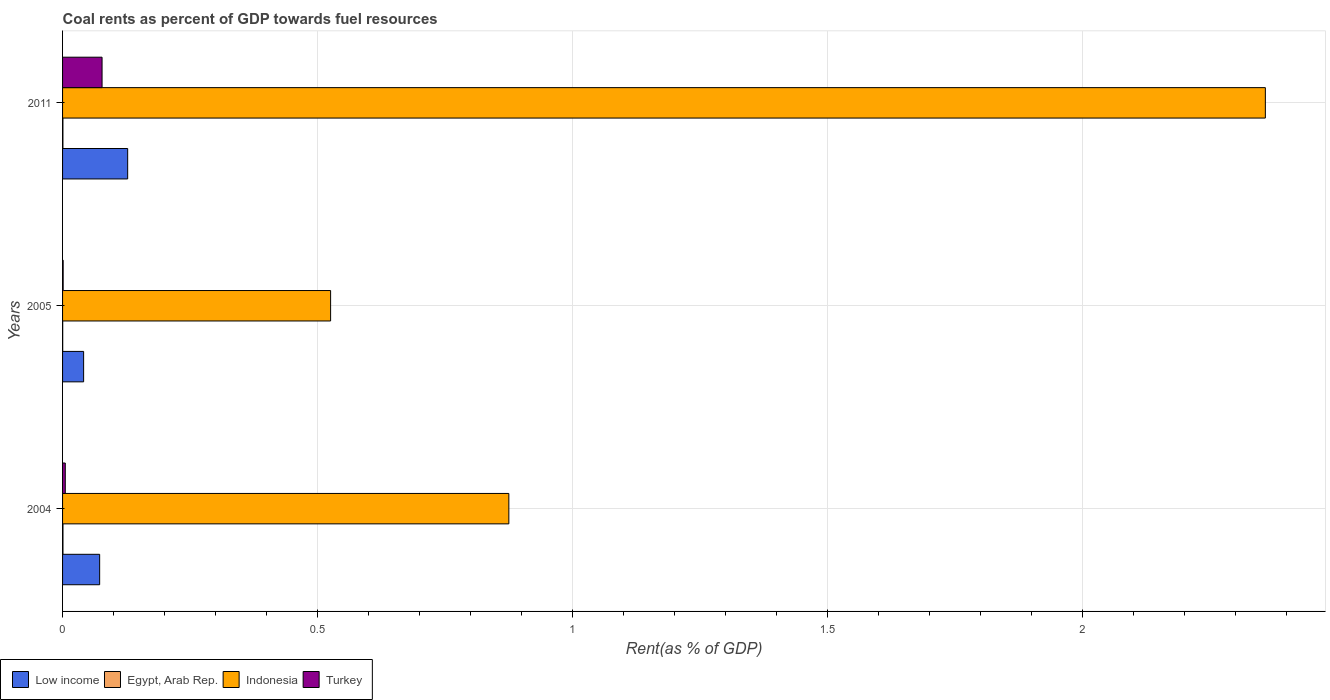How many groups of bars are there?
Offer a very short reply. 3. Are the number of bars on each tick of the Y-axis equal?
Ensure brevity in your answer.  Yes. How many bars are there on the 3rd tick from the top?
Offer a very short reply. 4. What is the coal rent in Indonesia in 2011?
Give a very brief answer. 2.36. Across all years, what is the maximum coal rent in Turkey?
Provide a short and direct response. 0.08. Across all years, what is the minimum coal rent in Low income?
Provide a short and direct response. 0.04. In which year was the coal rent in Turkey minimum?
Give a very brief answer. 2005. What is the total coal rent in Turkey in the graph?
Ensure brevity in your answer.  0.08. What is the difference between the coal rent in Low income in 2005 and that in 2011?
Make the answer very short. -0.09. What is the difference between the coal rent in Turkey in 2005 and the coal rent in Low income in 2011?
Offer a terse response. -0.13. What is the average coal rent in Turkey per year?
Provide a short and direct response. 0.03. In the year 2004, what is the difference between the coal rent in Egypt, Arab Rep. and coal rent in Turkey?
Offer a terse response. -0. What is the ratio of the coal rent in Indonesia in 2004 to that in 2011?
Your answer should be very brief. 0.37. Is the coal rent in Indonesia in 2004 less than that in 2011?
Offer a terse response. Yes. What is the difference between the highest and the second highest coal rent in Turkey?
Offer a very short reply. 0.07. What is the difference between the highest and the lowest coal rent in Indonesia?
Provide a succinct answer. 1.83. In how many years, is the coal rent in Turkey greater than the average coal rent in Turkey taken over all years?
Provide a succinct answer. 1. What does the 4th bar from the top in 2004 represents?
Provide a short and direct response. Low income. How many bars are there?
Make the answer very short. 12. Does the graph contain any zero values?
Make the answer very short. No. Where does the legend appear in the graph?
Ensure brevity in your answer.  Bottom left. How many legend labels are there?
Your answer should be compact. 4. How are the legend labels stacked?
Your response must be concise. Horizontal. What is the title of the graph?
Keep it short and to the point. Coal rents as percent of GDP towards fuel resources. Does "Lao PDR" appear as one of the legend labels in the graph?
Ensure brevity in your answer.  No. What is the label or title of the X-axis?
Ensure brevity in your answer.  Rent(as % of GDP). What is the label or title of the Y-axis?
Make the answer very short. Years. What is the Rent(as % of GDP) of Low income in 2004?
Your response must be concise. 0.07. What is the Rent(as % of GDP) in Egypt, Arab Rep. in 2004?
Ensure brevity in your answer.  0. What is the Rent(as % of GDP) of Indonesia in 2004?
Ensure brevity in your answer.  0.88. What is the Rent(as % of GDP) of Turkey in 2004?
Make the answer very short. 0.01. What is the Rent(as % of GDP) of Low income in 2005?
Ensure brevity in your answer.  0.04. What is the Rent(as % of GDP) in Egypt, Arab Rep. in 2005?
Make the answer very short. 0. What is the Rent(as % of GDP) in Indonesia in 2005?
Give a very brief answer. 0.53. What is the Rent(as % of GDP) of Turkey in 2005?
Provide a succinct answer. 0. What is the Rent(as % of GDP) in Low income in 2011?
Offer a terse response. 0.13. What is the Rent(as % of GDP) in Egypt, Arab Rep. in 2011?
Your answer should be very brief. 0. What is the Rent(as % of GDP) in Indonesia in 2011?
Your answer should be compact. 2.36. What is the Rent(as % of GDP) of Turkey in 2011?
Your response must be concise. 0.08. Across all years, what is the maximum Rent(as % of GDP) in Low income?
Provide a short and direct response. 0.13. Across all years, what is the maximum Rent(as % of GDP) of Egypt, Arab Rep.?
Offer a very short reply. 0. Across all years, what is the maximum Rent(as % of GDP) in Indonesia?
Provide a succinct answer. 2.36. Across all years, what is the maximum Rent(as % of GDP) of Turkey?
Offer a terse response. 0.08. Across all years, what is the minimum Rent(as % of GDP) in Low income?
Ensure brevity in your answer.  0.04. Across all years, what is the minimum Rent(as % of GDP) in Egypt, Arab Rep.?
Your answer should be very brief. 0. Across all years, what is the minimum Rent(as % of GDP) in Indonesia?
Offer a very short reply. 0.53. Across all years, what is the minimum Rent(as % of GDP) of Turkey?
Offer a very short reply. 0. What is the total Rent(as % of GDP) in Low income in the graph?
Your answer should be very brief. 0.24. What is the total Rent(as % of GDP) in Egypt, Arab Rep. in the graph?
Your answer should be compact. 0. What is the total Rent(as % of GDP) in Indonesia in the graph?
Offer a very short reply. 3.76. What is the total Rent(as % of GDP) of Turkey in the graph?
Your response must be concise. 0.08. What is the difference between the Rent(as % of GDP) of Low income in 2004 and that in 2005?
Keep it short and to the point. 0.03. What is the difference between the Rent(as % of GDP) in Egypt, Arab Rep. in 2004 and that in 2005?
Give a very brief answer. 0. What is the difference between the Rent(as % of GDP) of Indonesia in 2004 and that in 2005?
Provide a short and direct response. 0.35. What is the difference between the Rent(as % of GDP) in Turkey in 2004 and that in 2005?
Offer a terse response. 0. What is the difference between the Rent(as % of GDP) of Low income in 2004 and that in 2011?
Provide a short and direct response. -0.05. What is the difference between the Rent(as % of GDP) of Indonesia in 2004 and that in 2011?
Offer a terse response. -1.48. What is the difference between the Rent(as % of GDP) in Turkey in 2004 and that in 2011?
Your answer should be very brief. -0.07. What is the difference between the Rent(as % of GDP) in Low income in 2005 and that in 2011?
Ensure brevity in your answer.  -0.09. What is the difference between the Rent(as % of GDP) of Egypt, Arab Rep. in 2005 and that in 2011?
Offer a very short reply. -0. What is the difference between the Rent(as % of GDP) of Indonesia in 2005 and that in 2011?
Your answer should be compact. -1.83. What is the difference between the Rent(as % of GDP) of Turkey in 2005 and that in 2011?
Offer a terse response. -0.08. What is the difference between the Rent(as % of GDP) of Low income in 2004 and the Rent(as % of GDP) of Egypt, Arab Rep. in 2005?
Offer a very short reply. 0.07. What is the difference between the Rent(as % of GDP) in Low income in 2004 and the Rent(as % of GDP) in Indonesia in 2005?
Give a very brief answer. -0.45. What is the difference between the Rent(as % of GDP) of Low income in 2004 and the Rent(as % of GDP) of Turkey in 2005?
Offer a terse response. 0.07. What is the difference between the Rent(as % of GDP) in Egypt, Arab Rep. in 2004 and the Rent(as % of GDP) in Indonesia in 2005?
Your response must be concise. -0.52. What is the difference between the Rent(as % of GDP) of Egypt, Arab Rep. in 2004 and the Rent(as % of GDP) of Turkey in 2005?
Provide a succinct answer. -0. What is the difference between the Rent(as % of GDP) of Indonesia in 2004 and the Rent(as % of GDP) of Turkey in 2005?
Ensure brevity in your answer.  0.87. What is the difference between the Rent(as % of GDP) of Low income in 2004 and the Rent(as % of GDP) of Egypt, Arab Rep. in 2011?
Give a very brief answer. 0.07. What is the difference between the Rent(as % of GDP) in Low income in 2004 and the Rent(as % of GDP) in Indonesia in 2011?
Your answer should be compact. -2.29. What is the difference between the Rent(as % of GDP) of Low income in 2004 and the Rent(as % of GDP) of Turkey in 2011?
Ensure brevity in your answer.  -0. What is the difference between the Rent(as % of GDP) in Egypt, Arab Rep. in 2004 and the Rent(as % of GDP) in Indonesia in 2011?
Make the answer very short. -2.36. What is the difference between the Rent(as % of GDP) in Egypt, Arab Rep. in 2004 and the Rent(as % of GDP) in Turkey in 2011?
Offer a very short reply. -0.08. What is the difference between the Rent(as % of GDP) of Indonesia in 2004 and the Rent(as % of GDP) of Turkey in 2011?
Offer a very short reply. 0.8. What is the difference between the Rent(as % of GDP) in Low income in 2005 and the Rent(as % of GDP) in Egypt, Arab Rep. in 2011?
Your answer should be very brief. 0.04. What is the difference between the Rent(as % of GDP) in Low income in 2005 and the Rent(as % of GDP) in Indonesia in 2011?
Provide a short and direct response. -2.32. What is the difference between the Rent(as % of GDP) of Low income in 2005 and the Rent(as % of GDP) of Turkey in 2011?
Your response must be concise. -0.04. What is the difference between the Rent(as % of GDP) of Egypt, Arab Rep. in 2005 and the Rent(as % of GDP) of Indonesia in 2011?
Provide a short and direct response. -2.36. What is the difference between the Rent(as % of GDP) of Egypt, Arab Rep. in 2005 and the Rent(as % of GDP) of Turkey in 2011?
Provide a succinct answer. -0.08. What is the difference between the Rent(as % of GDP) in Indonesia in 2005 and the Rent(as % of GDP) in Turkey in 2011?
Provide a short and direct response. 0.45. What is the average Rent(as % of GDP) in Low income per year?
Provide a succinct answer. 0.08. What is the average Rent(as % of GDP) in Egypt, Arab Rep. per year?
Make the answer very short. 0. What is the average Rent(as % of GDP) of Indonesia per year?
Ensure brevity in your answer.  1.25. What is the average Rent(as % of GDP) of Turkey per year?
Ensure brevity in your answer.  0.03. In the year 2004, what is the difference between the Rent(as % of GDP) of Low income and Rent(as % of GDP) of Egypt, Arab Rep.?
Provide a short and direct response. 0.07. In the year 2004, what is the difference between the Rent(as % of GDP) of Low income and Rent(as % of GDP) of Indonesia?
Ensure brevity in your answer.  -0.8. In the year 2004, what is the difference between the Rent(as % of GDP) in Low income and Rent(as % of GDP) in Turkey?
Provide a short and direct response. 0.07. In the year 2004, what is the difference between the Rent(as % of GDP) of Egypt, Arab Rep. and Rent(as % of GDP) of Indonesia?
Your response must be concise. -0.87. In the year 2004, what is the difference between the Rent(as % of GDP) in Egypt, Arab Rep. and Rent(as % of GDP) in Turkey?
Provide a succinct answer. -0. In the year 2004, what is the difference between the Rent(as % of GDP) of Indonesia and Rent(as % of GDP) of Turkey?
Your answer should be compact. 0.87. In the year 2005, what is the difference between the Rent(as % of GDP) of Low income and Rent(as % of GDP) of Egypt, Arab Rep.?
Your answer should be compact. 0.04. In the year 2005, what is the difference between the Rent(as % of GDP) in Low income and Rent(as % of GDP) in Indonesia?
Keep it short and to the point. -0.48. In the year 2005, what is the difference between the Rent(as % of GDP) in Low income and Rent(as % of GDP) in Turkey?
Your response must be concise. 0.04. In the year 2005, what is the difference between the Rent(as % of GDP) in Egypt, Arab Rep. and Rent(as % of GDP) in Indonesia?
Make the answer very short. -0.53. In the year 2005, what is the difference between the Rent(as % of GDP) in Egypt, Arab Rep. and Rent(as % of GDP) in Turkey?
Your response must be concise. -0. In the year 2005, what is the difference between the Rent(as % of GDP) of Indonesia and Rent(as % of GDP) of Turkey?
Your response must be concise. 0.52. In the year 2011, what is the difference between the Rent(as % of GDP) in Low income and Rent(as % of GDP) in Egypt, Arab Rep.?
Make the answer very short. 0.13. In the year 2011, what is the difference between the Rent(as % of GDP) in Low income and Rent(as % of GDP) in Indonesia?
Offer a very short reply. -2.23. In the year 2011, what is the difference between the Rent(as % of GDP) of Low income and Rent(as % of GDP) of Turkey?
Provide a succinct answer. 0.05. In the year 2011, what is the difference between the Rent(as % of GDP) in Egypt, Arab Rep. and Rent(as % of GDP) in Indonesia?
Keep it short and to the point. -2.36. In the year 2011, what is the difference between the Rent(as % of GDP) in Egypt, Arab Rep. and Rent(as % of GDP) in Turkey?
Keep it short and to the point. -0.08. In the year 2011, what is the difference between the Rent(as % of GDP) of Indonesia and Rent(as % of GDP) of Turkey?
Your answer should be compact. 2.28. What is the ratio of the Rent(as % of GDP) of Low income in 2004 to that in 2005?
Provide a short and direct response. 1.76. What is the ratio of the Rent(as % of GDP) in Egypt, Arab Rep. in 2004 to that in 2005?
Give a very brief answer. 2.83. What is the ratio of the Rent(as % of GDP) of Indonesia in 2004 to that in 2005?
Keep it short and to the point. 1.67. What is the ratio of the Rent(as % of GDP) in Turkey in 2004 to that in 2005?
Ensure brevity in your answer.  4.63. What is the ratio of the Rent(as % of GDP) in Low income in 2004 to that in 2011?
Give a very brief answer. 0.57. What is the ratio of the Rent(as % of GDP) in Egypt, Arab Rep. in 2004 to that in 2011?
Your answer should be compact. 1.13. What is the ratio of the Rent(as % of GDP) in Indonesia in 2004 to that in 2011?
Give a very brief answer. 0.37. What is the ratio of the Rent(as % of GDP) in Turkey in 2004 to that in 2011?
Make the answer very short. 0.07. What is the ratio of the Rent(as % of GDP) in Low income in 2005 to that in 2011?
Provide a short and direct response. 0.32. What is the ratio of the Rent(as % of GDP) of Egypt, Arab Rep. in 2005 to that in 2011?
Keep it short and to the point. 0.4. What is the ratio of the Rent(as % of GDP) of Indonesia in 2005 to that in 2011?
Provide a short and direct response. 0.22. What is the ratio of the Rent(as % of GDP) of Turkey in 2005 to that in 2011?
Offer a terse response. 0.01. What is the difference between the highest and the second highest Rent(as % of GDP) of Low income?
Offer a terse response. 0.05. What is the difference between the highest and the second highest Rent(as % of GDP) of Egypt, Arab Rep.?
Your answer should be very brief. 0. What is the difference between the highest and the second highest Rent(as % of GDP) of Indonesia?
Give a very brief answer. 1.48. What is the difference between the highest and the second highest Rent(as % of GDP) of Turkey?
Your response must be concise. 0.07. What is the difference between the highest and the lowest Rent(as % of GDP) in Low income?
Keep it short and to the point. 0.09. What is the difference between the highest and the lowest Rent(as % of GDP) of Egypt, Arab Rep.?
Make the answer very short. 0. What is the difference between the highest and the lowest Rent(as % of GDP) of Indonesia?
Your answer should be very brief. 1.83. What is the difference between the highest and the lowest Rent(as % of GDP) of Turkey?
Offer a terse response. 0.08. 